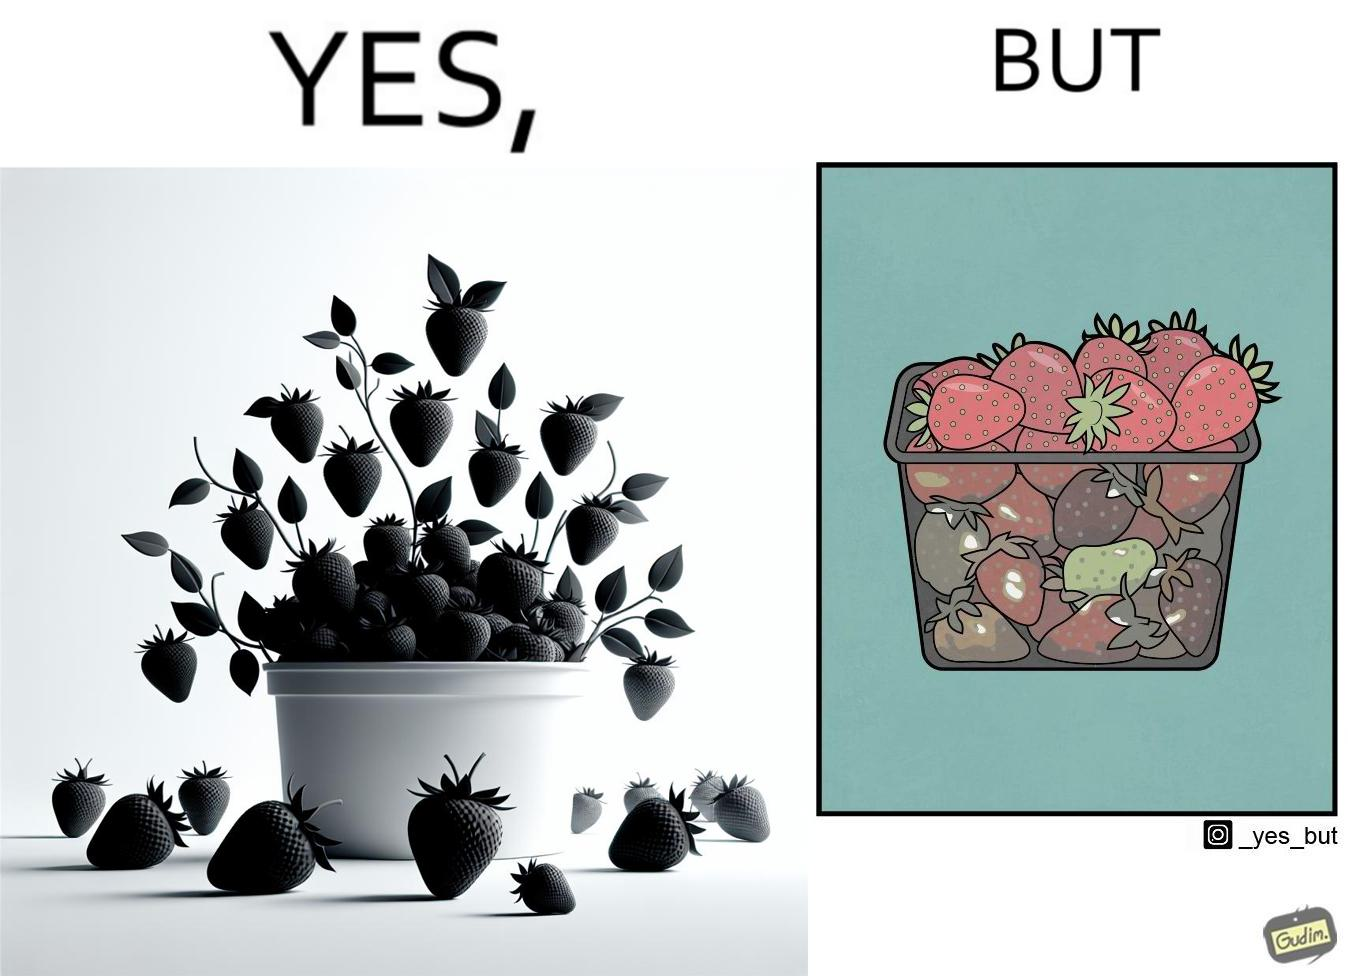What is shown in the left half versus the right half of this image? In the left part of the image: fresh strawberries in a container In the right part of the image: a container transparent from one of the sides, containing fresh strawberries at the top, and bad quality ones at the bottom. 